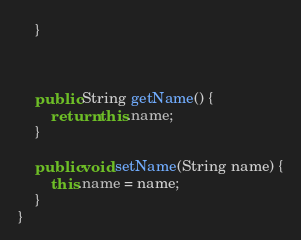Convert code to text. <code><loc_0><loc_0><loc_500><loc_500><_Java_>    }

    

    public String getName() {
        return this.name;
    }

    public void setName(String name) {
        this.name = name;
    }
}
</code> 